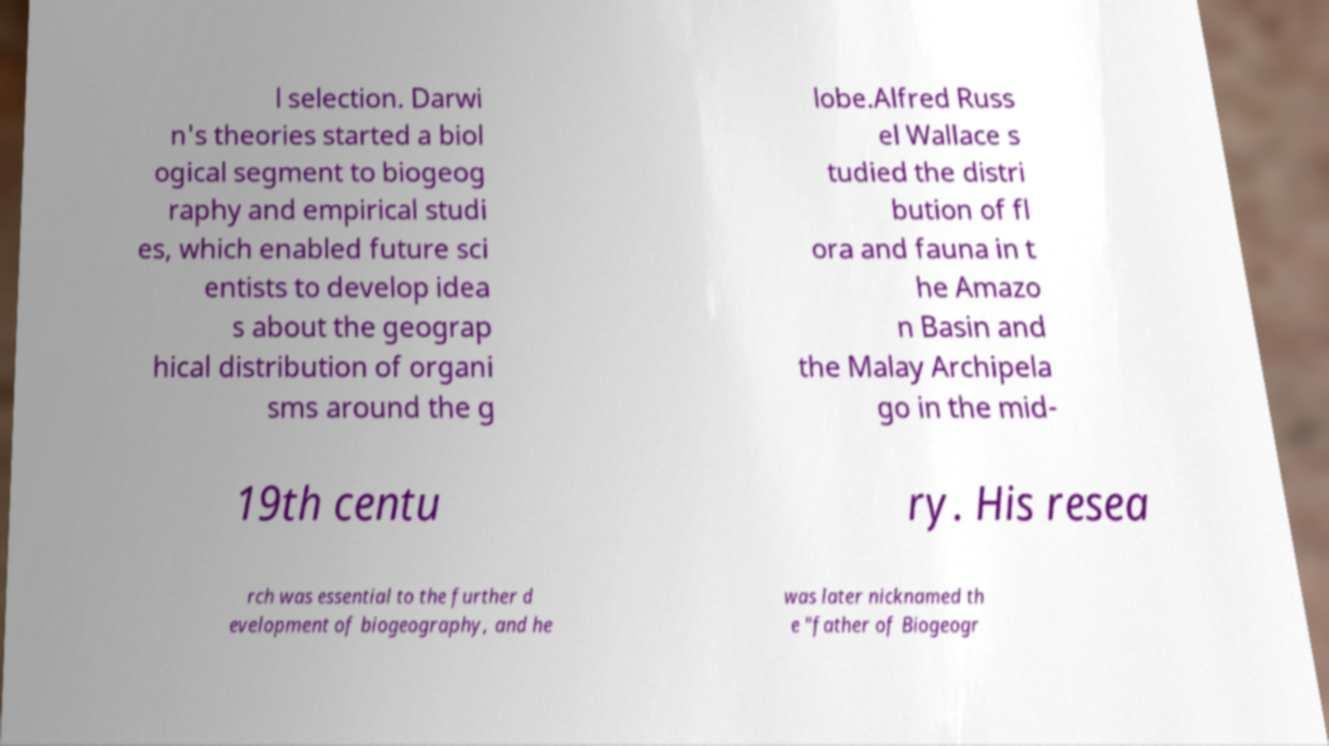There's text embedded in this image that I need extracted. Can you transcribe it verbatim? l selection. Darwi n's theories started a biol ogical segment to biogeog raphy and empirical studi es, which enabled future sci entists to develop idea s about the geograp hical distribution of organi sms around the g lobe.Alfred Russ el Wallace s tudied the distri bution of fl ora and fauna in t he Amazo n Basin and the Malay Archipela go in the mid- 19th centu ry. His resea rch was essential to the further d evelopment of biogeography, and he was later nicknamed th e "father of Biogeogr 